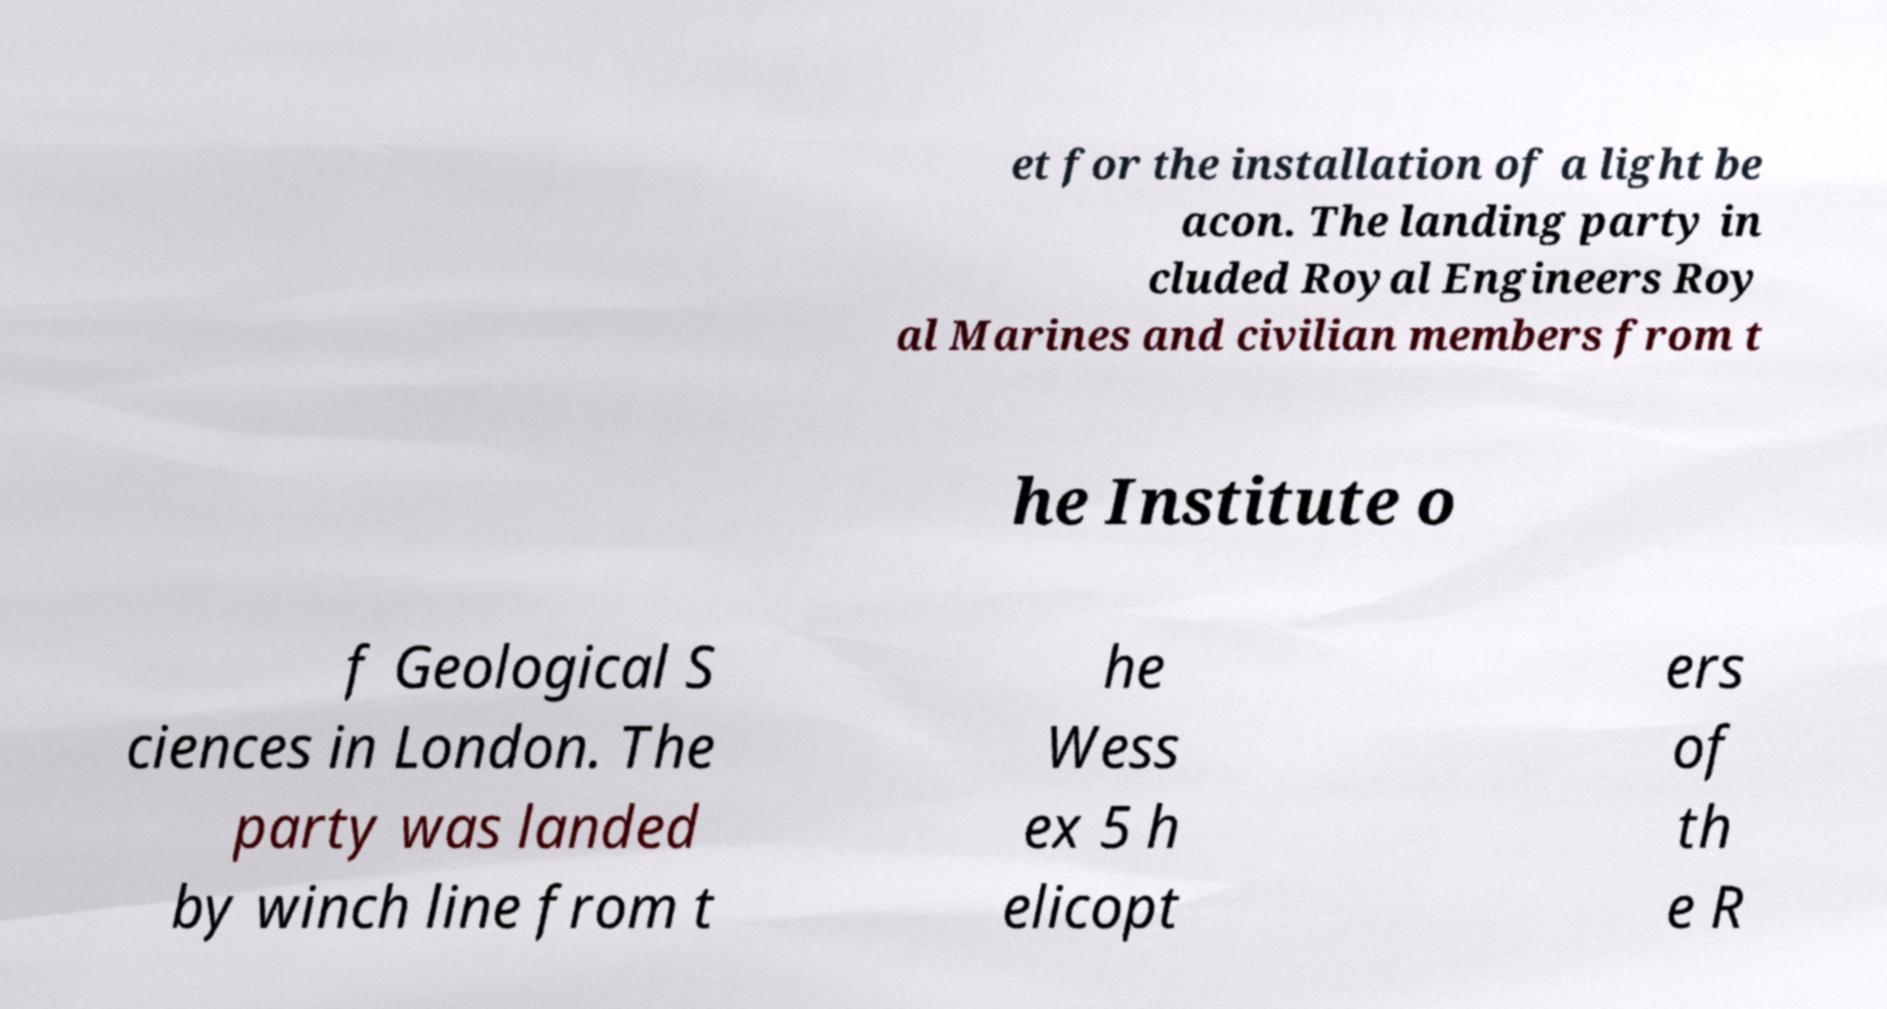Could you extract and type out the text from this image? et for the installation of a light be acon. The landing party in cluded Royal Engineers Roy al Marines and civilian members from t he Institute o f Geological S ciences in London. The party was landed by winch line from t he Wess ex 5 h elicopt ers of th e R 